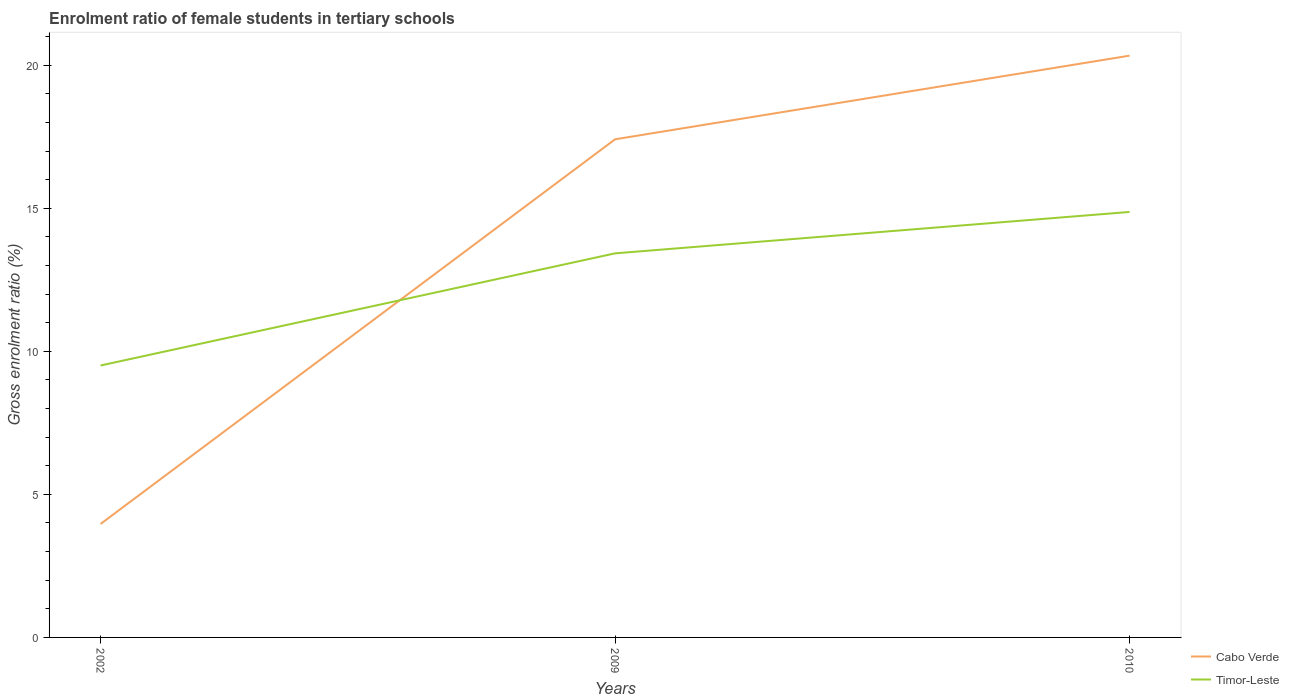Across all years, what is the maximum enrolment ratio of female students in tertiary schools in Timor-Leste?
Give a very brief answer. 9.5. What is the total enrolment ratio of female students in tertiary schools in Cabo Verde in the graph?
Your answer should be very brief. -2.92. What is the difference between the highest and the second highest enrolment ratio of female students in tertiary schools in Cabo Verde?
Your answer should be very brief. 16.37. What is the difference between the highest and the lowest enrolment ratio of female students in tertiary schools in Cabo Verde?
Provide a succinct answer. 2. Does the graph contain any zero values?
Your answer should be compact. No. Does the graph contain grids?
Provide a short and direct response. No. Where does the legend appear in the graph?
Your answer should be very brief. Bottom right. How many legend labels are there?
Give a very brief answer. 2. How are the legend labels stacked?
Provide a short and direct response. Vertical. What is the title of the graph?
Ensure brevity in your answer.  Enrolment ratio of female students in tertiary schools. What is the label or title of the Y-axis?
Ensure brevity in your answer.  Gross enrolment ratio (%). What is the Gross enrolment ratio (%) of Cabo Verde in 2002?
Your response must be concise. 3.97. What is the Gross enrolment ratio (%) in Timor-Leste in 2002?
Your response must be concise. 9.5. What is the Gross enrolment ratio (%) in Cabo Verde in 2009?
Keep it short and to the point. 17.41. What is the Gross enrolment ratio (%) in Timor-Leste in 2009?
Your answer should be compact. 13.42. What is the Gross enrolment ratio (%) of Cabo Verde in 2010?
Provide a succinct answer. 20.33. What is the Gross enrolment ratio (%) of Timor-Leste in 2010?
Provide a succinct answer. 14.87. Across all years, what is the maximum Gross enrolment ratio (%) in Cabo Verde?
Your answer should be compact. 20.33. Across all years, what is the maximum Gross enrolment ratio (%) of Timor-Leste?
Keep it short and to the point. 14.87. Across all years, what is the minimum Gross enrolment ratio (%) of Cabo Verde?
Your answer should be compact. 3.97. Across all years, what is the minimum Gross enrolment ratio (%) in Timor-Leste?
Your response must be concise. 9.5. What is the total Gross enrolment ratio (%) in Cabo Verde in the graph?
Provide a succinct answer. 41.71. What is the total Gross enrolment ratio (%) in Timor-Leste in the graph?
Provide a succinct answer. 37.8. What is the difference between the Gross enrolment ratio (%) of Cabo Verde in 2002 and that in 2009?
Your answer should be compact. -13.44. What is the difference between the Gross enrolment ratio (%) of Timor-Leste in 2002 and that in 2009?
Your answer should be compact. -3.92. What is the difference between the Gross enrolment ratio (%) in Cabo Verde in 2002 and that in 2010?
Offer a very short reply. -16.37. What is the difference between the Gross enrolment ratio (%) in Timor-Leste in 2002 and that in 2010?
Give a very brief answer. -5.37. What is the difference between the Gross enrolment ratio (%) of Cabo Verde in 2009 and that in 2010?
Make the answer very short. -2.92. What is the difference between the Gross enrolment ratio (%) of Timor-Leste in 2009 and that in 2010?
Provide a succinct answer. -1.45. What is the difference between the Gross enrolment ratio (%) of Cabo Verde in 2002 and the Gross enrolment ratio (%) of Timor-Leste in 2009?
Give a very brief answer. -9.46. What is the difference between the Gross enrolment ratio (%) in Cabo Verde in 2002 and the Gross enrolment ratio (%) in Timor-Leste in 2010?
Ensure brevity in your answer.  -10.91. What is the difference between the Gross enrolment ratio (%) of Cabo Verde in 2009 and the Gross enrolment ratio (%) of Timor-Leste in 2010?
Make the answer very short. 2.54. What is the average Gross enrolment ratio (%) of Cabo Verde per year?
Keep it short and to the point. 13.9. What is the average Gross enrolment ratio (%) of Timor-Leste per year?
Make the answer very short. 12.6. In the year 2002, what is the difference between the Gross enrolment ratio (%) of Cabo Verde and Gross enrolment ratio (%) of Timor-Leste?
Provide a succinct answer. -5.54. In the year 2009, what is the difference between the Gross enrolment ratio (%) in Cabo Verde and Gross enrolment ratio (%) in Timor-Leste?
Your response must be concise. 3.99. In the year 2010, what is the difference between the Gross enrolment ratio (%) in Cabo Verde and Gross enrolment ratio (%) in Timor-Leste?
Keep it short and to the point. 5.46. What is the ratio of the Gross enrolment ratio (%) of Cabo Verde in 2002 to that in 2009?
Your response must be concise. 0.23. What is the ratio of the Gross enrolment ratio (%) in Timor-Leste in 2002 to that in 2009?
Offer a very short reply. 0.71. What is the ratio of the Gross enrolment ratio (%) in Cabo Verde in 2002 to that in 2010?
Provide a succinct answer. 0.2. What is the ratio of the Gross enrolment ratio (%) in Timor-Leste in 2002 to that in 2010?
Your answer should be compact. 0.64. What is the ratio of the Gross enrolment ratio (%) in Cabo Verde in 2009 to that in 2010?
Your answer should be compact. 0.86. What is the ratio of the Gross enrolment ratio (%) of Timor-Leste in 2009 to that in 2010?
Offer a terse response. 0.9. What is the difference between the highest and the second highest Gross enrolment ratio (%) of Cabo Verde?
Provide a short and direct response. 2.92. What is the difference between the highest and the second highest Gross enrolment ratio (%) in Timor-Leste?
Keep it short and to the point. 1.45. What is the difference between the highest and the lowest Gross enrolment ratio (%) in Cabo Verde?
Offer a terse response. 16.37. What is the difference between the highest and the lowest Gross enrolment ratio (%) of Timor-Leste?
Give a very brief answer. 5.37. 